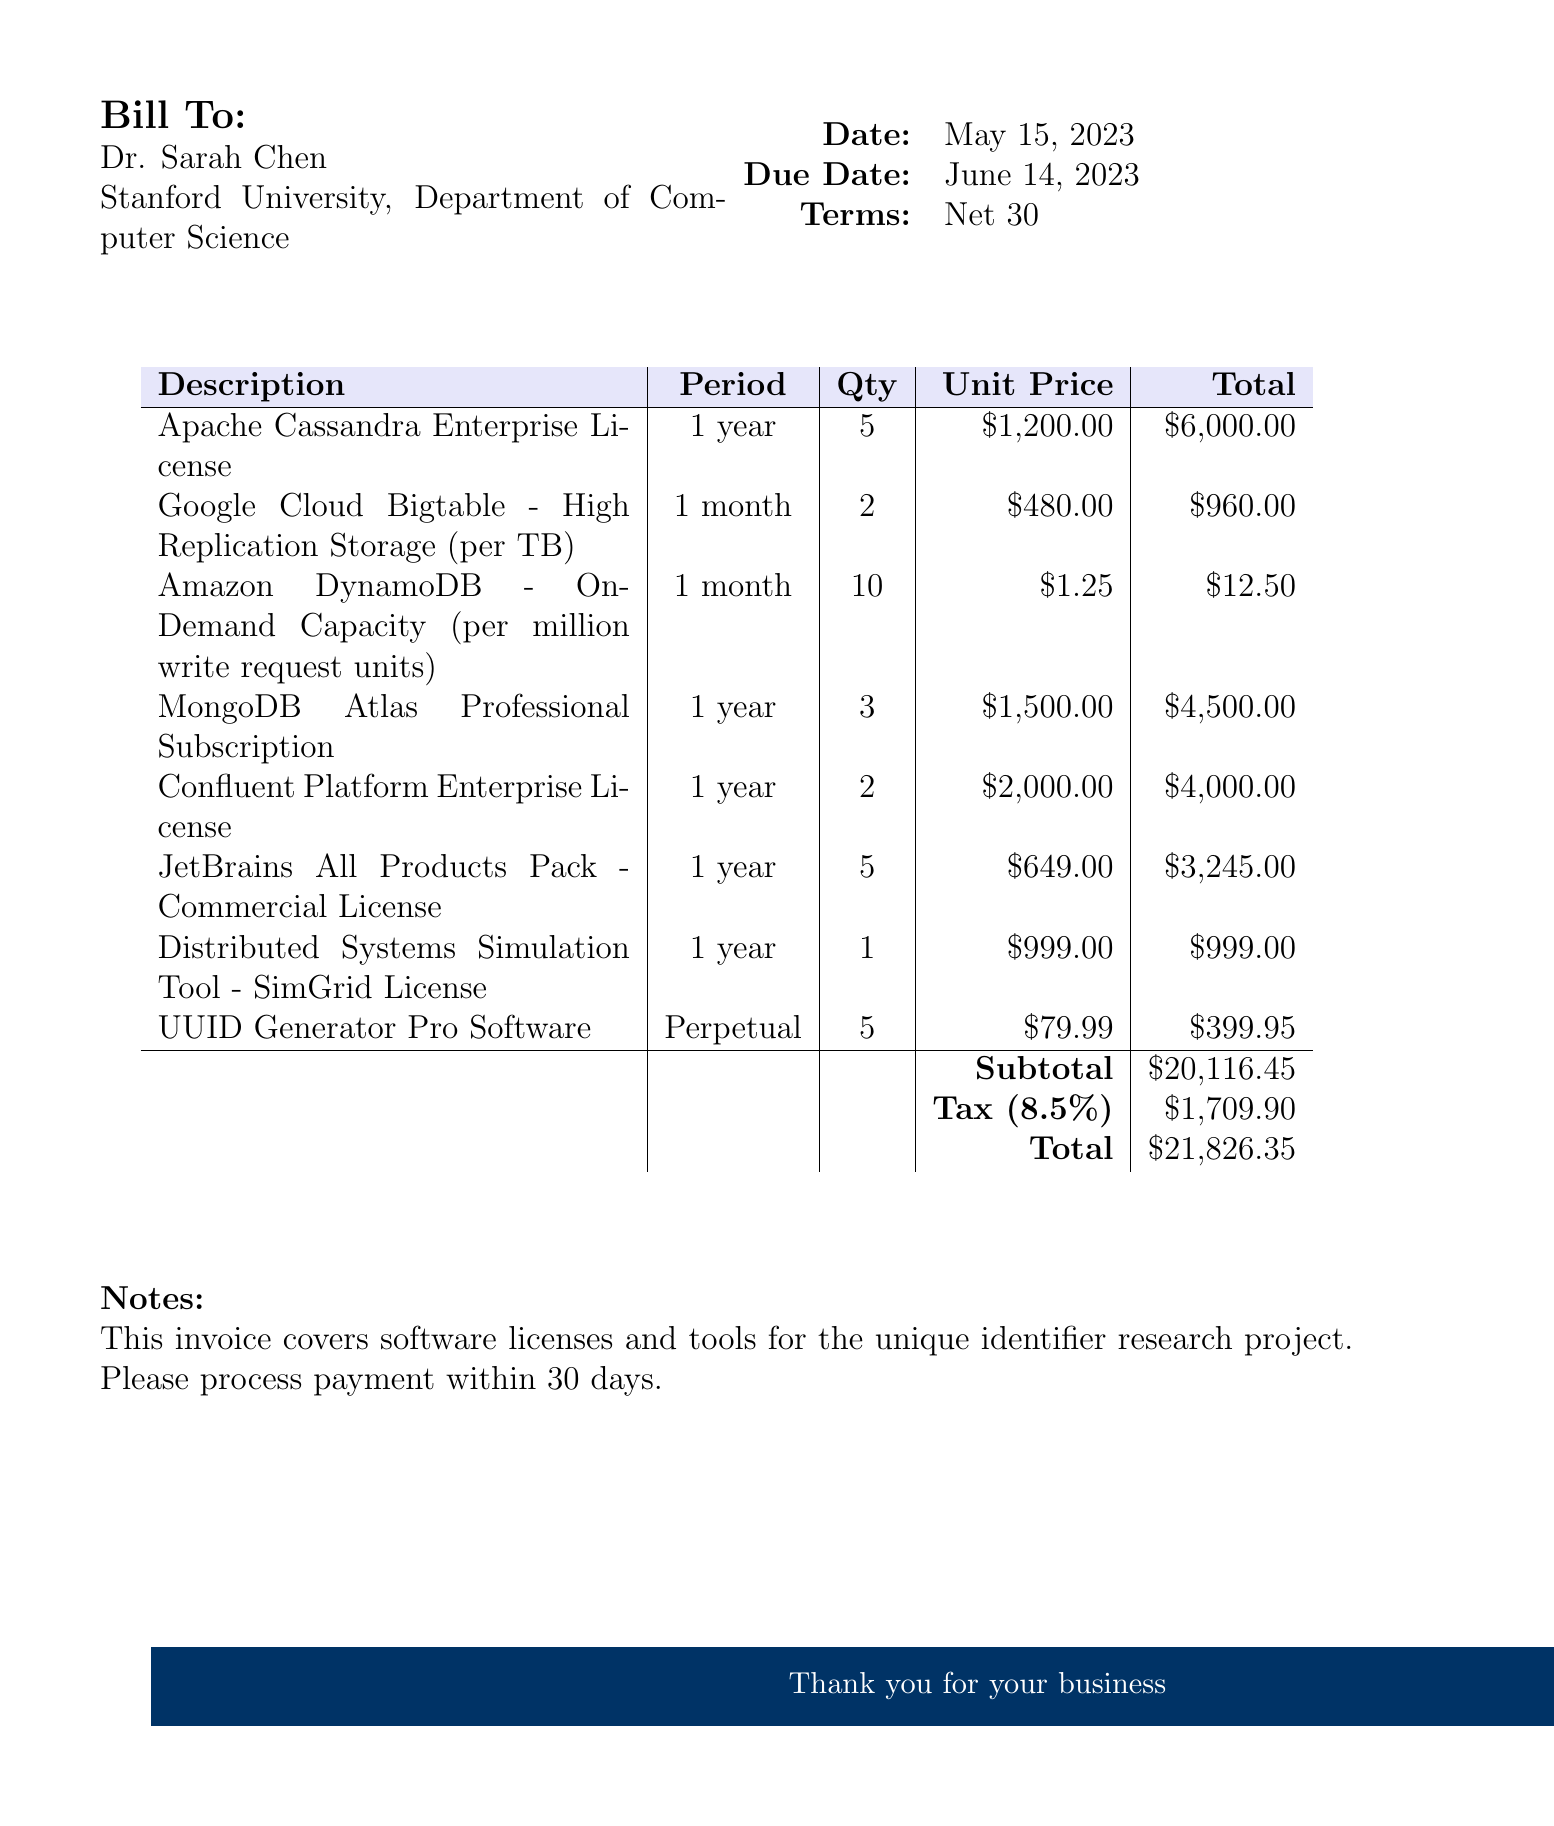what is the invoice number? The invoice number is stated at the top of the document to uniquely identify this transaction.
Answer: INV-2023-0587 who is the client? The client is listed under the "Bill To" section of the invoice, which includes the name and institution.
Answer: Dr. Sarah Chen what is the due date of the invoice? The due date is provided next to the date in the document to indicate when payment is expected.
Answer: June 14, 2023 how many Apache Cassandra Enterprise Licenses were purchased? The quantity of each item purchased is detailed in the invoice, showing how many of each license were obtained.
Answer: 5 what is the total amount due? The total amount is calculated by adding the subtotal and tax and is listed in the invoice summary.
Answer: $21,826.35 how long is the subscription period for MongoDB Atlas Professional Subscription? The subscription period indicates the duration for which the license is valid, as stated in the item description.
Answer: 1 year what is the unit price of the UUID Generator Pro Software? The unit price is specified for each item in the invoice to clarify the cost of individual licenses.
Answer: $79.99 what percentage is the tax applied on the subtotal? The tax rate is mentioned in the invoice, showing how much tax is applied to the subtotal amount.
Answer: 8.5% what type of document is this? The document type is specified at the beginning, which identifies its purpose and the nature of its contents.
Answer: Invoice 